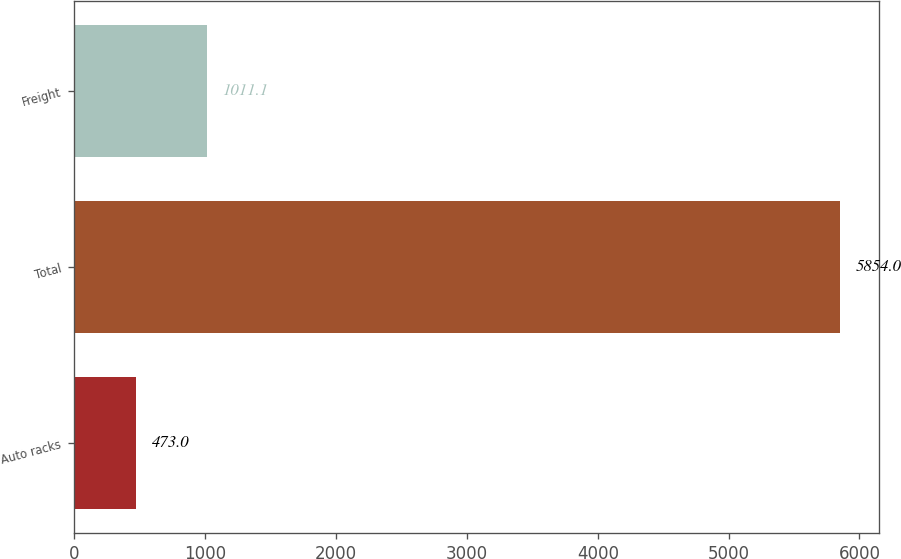Convert chart to OTSL. <chart><loc_0><loc_0><loc_500><loc_500><bar_chart><fcel>Auto racks<fcel>Total<fcel>Freight<nl><fcel>473<fcel>5854<fcel>1011.1<nl></chart> 